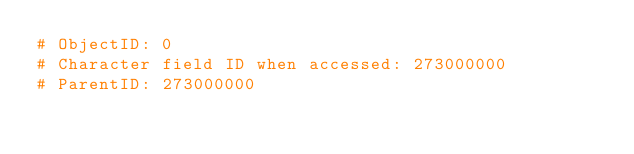Convert code to text. <code><loc_0><loc_0><loc_500><loc_500><_Python_># ObjectID: 0
# Character field ID when accessed: 273000000
# ParentID: 273000000
</code> 